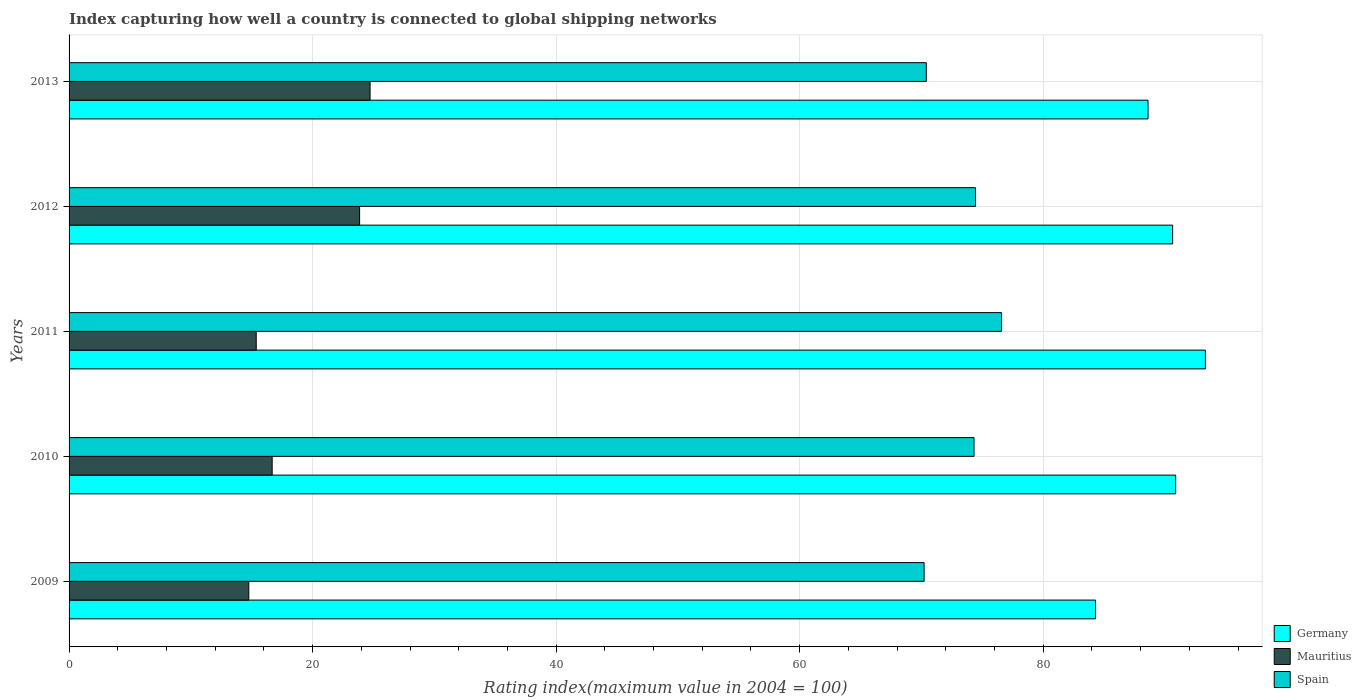How many groups of bars are there?
Give a very brief answer. 5. How many bars are there on the 4th tick from the top?
Your response must be concise. 3. In how many cases, is the number of bars for a given year not equal to the number of legend labels?
Your answer should be very brief. 0. What is the rating index in Mauritius in 2010?
Offer a very short reply. 16.68. Across all years, what is the maximum rating index in Germany?
Ensure brevity in your answer.  93.32. Across all years, what is the minimum rating index in Germany?
Give a very brief answer. 84.3. What is the total rating index in Mauritius in the graph?
Make the answer very short. 95.39. What is the difference between the rating index in Mauritius in 2009 and the rating index in Spain in 2011?
Offer a very short reply. -61.82. What is the average rating index in Spain per year?
Your response must be concise. 73.19. In the year 2009, what is the difference between the rating index in Spain and rating index in Germany?
Your answer should be very brief. -14.08. What is the ratio of the rating index in Germany in 2011 to that in 2013?
Your answer should be compact. 1.05. Is the rating index in Spain in 2011 less than that in 2012?
Give a very brief answer. No. What is the difference between the highest and the second highest rating index in Spain?
Your answer should be very brief. 2.14. What is the difference between the highest and the lowest rating index in Germany?
Keep it short and to the point. 9.02. In how many years, is the rating index in Germany greater than the average rating index in Germany taken over all years?
Provide a succinct answer. 3. What does the 2nd bar from the bottom in 2013 represents?
Your answer should be very brief. Mauritius. How many bars are there?
Provide a short and direct response. 15. Does the graph contain any zero values?
Provide a short and direct response. No. How are the legend labels stacked?
Ensure brevity in your answer.  Vertical. What is the title of the graph?
Your response must be concise. Index capturing how well a country is connected to global shipping networks. Does "Serbia" appear as one of the legend labels in the graph?
Your answer should be very brief. No. What is the label or title of the X-axis?
Make the answer very short. Rating index(maximum value in 2004 = 100). What is the label or title of the Y-axis?
Keep it short and to the point. Years. What is the Rating index(maximum value in 2004 = 100) in Germany in 2009?
Your answer should be compact. 84.3. What is the Rating index(maximum value in 2004 = 100) of Mauritius in 2009?
Make the answer very short. 14.76. What is the Rating index(maximum value in 2004 = 100) in Spain in 2009?
Provide a short and direct response. 70.22. What is the Rating index(maximum value in 2004 = 100) in Germany in 2010?
Give a very brief answer. 90.88. What is the Rating index(maximum value in 2004 = 100) of Mauritius in 2010?
Your answer should be compact. 16.68. What is the Rating index(maximum value in 2004 = 100) in Spain in 2010?
Your answer should be very brief. 74.32. What is the Rating index(maximum value in 2004 = 100) in Germany in 2011?
Your response must be concise. 93.32. What is the Rating index(maximum value in 2004 = 100) in Mauritius in 2011?
Provide a succinct answer. 15.37. What is the Rating index(maximum value in 2004 = 100) of Spain in 2011?
Your answer should be very brief. 76.58. What is the Rating index(maximum value in 2004 = 100) of Germany in 2012?
Make the answer very short. 90.63. What is the Rating index(maximum value in 2004 = 100) in Mauritius in 2012?
Offer a very short reply. 23.86. What is the Rating index(maximum value in 2004 = 100) of Spain in 2012?
Your answer should be compact. 74.44. What is the Rating index(maximum value in 2004 = 100) of Germany in 2013?
Give a very brief answer. 88.61. What is the Rating index(maximum value in 2004 = 100) in Mauritius in 2013?
Offer a terse response. 24.72. What is the Rating index(maximum value in 2004 = 100) in Spain in 2013?
Your answer should be compact. 70.4. Across all years, what is the maximum Rating index(maximum value in 2004 = 100) in Germany?
Give a very brief answer. 93.32. Across all years, what is the maximum Rating index(maximum value in 2004 = 100) of Mauritius?
Give a very brief answer. 24.72. Across all years, what is the maximum Rating index(maximum value in 2004 = 100) of Spain?
Your answer should be compact. 76.58. Across all years, what is the minimum Rating index(maximum value in 2004 = 100) in Germany?
Ensure brevity in your answer.  84.3. Across all years, what is the minimum Rating index(maximum value in 2004 = 100) of Mauritius?
Give a very brief answer. 14.76. Across all years, what is the minimum Rating index(maximum value in 2004 = 100) in Spain?
Keep it short and to the point. 70.22. What is the total Rating index(maximum value in 2004 = 100) in Germany in the graph?
Keep it short and to the point. 447.74. What is the total Rating index(maximum value in 2004 = 100) of Mauritius in the graph?
Your response must be concise. 95.39. What is the total Rating index(maximum value in 2004 = 100) in Spain in the graph?
Your answer should be compact. 365.96. What is the difference between the Rating index(maximum value in 2004 = 100) in Germany in 2009 and that in 2010?
Give a very brief answer. -6.58. What is the difference between the Rating index(maximum value in 2004 = 100) in Mauritius in 2009 and that in 2010?
Your answer should be very brief. -1.92. What is the difference between the Rating index(maximum value in 2004 = 100) in Germany in 2009 and that in 2011?
Your answer should be compact. -9.02. What is the difference between the Rating index(maximum value in 2004 = 100) in Mauritius in 2009 and that in 2011?
Your answer should be very brief. -0.61. What is the difference between the Rating index(maximum value in 2004 = 100) in Spain in 2009 and that in 2011?
Ensure brevity in your answer.  -6.36. What is the difference between the Rating index(maximum value in 2004 = 100) in Germany in 2009 and that in 2012?
Offer a terse response. -6.33. What is the difference between the Rating index(maximum value in 2004 = 100) in Mauritius in 2009 and that in 2012?
Keep it short and to the point. -9.1. What is the difference between the Rating index(maximum value in 2004 = 100) of Spain in 2009 and that in 2012?
Offer a terse response. -4.22. What is the difference between the Rating index(maximum value in 2004 = 100) in Germany in 2009 and that in 2013?
Give a very brief answer. -4.31. What is the difference between the Rating index(maximum value in 2004 = 100) in Mauritius in 2009 and that in 2013?
Provide a short and direct response. -9.96. What is the difference between the Rating index(maximum value in 2004 = 100) in Spain in 2009 and that in 2013?
Make the answer very short. -0.18. What is the difference between the Rating index(maximum value in 2004 = 100) in Germany in 2010 and that in 2011?
Offer a very short reply. -2.44. What is the difference between the Rating index(maximum value in 2004 = 100) of Mauritius in 2010 and that in 2011?
Give a very brief answer. 1.31. What is the difference between the Rating index(maximum value in 2004 = 100) in Spain in 2010 and that in 2011?
Make the answer very short. -2.26. What is the difference between the Rating index(maximum value in 2004 = 100) in Germany in 2010 and that in 2012?
Offer a terse response. 0.25. What is the difference between the Rating index(maximum value in 2004 = 100) in Mauritius in 2010 and that in 2012?
Make the answer very short. -7.18. What is the difference between the Rating index(maximum value in 2004 = 100) in Spain in 2010 and that in 2012?
Offer a terse response. -0.12. What is the difference between the Rating index(maximum value in 2004 = 100) in Germany in 2010 and that in 2013?
Offer a terse response. 2.27. What is the difference between the Rating index(maximum value in 2004 = 100) of Mauritius in 2010 and that in 2013?
Make the answer very short. -8.04. What is the difference between the Rating index(maximum value in 2004 = 100) in Spain in 2010 and that in 2013?
Your answer should be very brief. 3.92. What is the difference between the Rating index(maximum value in 2004 = 100) of Germany in 2011 and that in 2012?
Offer a very short reply. 2.69. What is the difference between the Rating index(maximum value in 2004 = 100) of Mauritius in 2011 and that in 2012?
Provide a succinct answer. -8.49. What is the difference between the Rating index(maximum value in 2004 = 100) of Spain in 2011 and that in 2012?
Offer a terse response. 2.14. What is the difference between the Rating index(maximum value in 2004 = 100) in Germany in 2011 and that in 2013?
Offer a very short reply. 4.71. What is the difference between the Rating index(maximum value in 2004 = 100) in Mauritius in 2011 and that in 2013?
Your response must be concise. -9.35. What is the difference between the Rating index(maximum value in 2004 = 100) of Spain in 2011 and that in 2013?
Make the answer very short. 6.18. What is the difference between the Rating index(maximum value in 2004 = 100) of Germany in 2012 and that in 2013?
Your answer should be compact. 2.02. What is the difference between the Rating index(maximum value in 2004 = 100) in Mauritius in 2012 and that in 2013?
Offer a very short reply. -0.86. What is the difference between the Rating index(maximum value in 2004 = 100) in Spain in 2012 and that in 2013?
Provide a short and direct response. 4.04. What is the difference between the Rating index(maximum value in 2004 = 100) of Germany in 2009 and the Rating index(maximum value in 2004 = 100) of Mauritius in 2010?
Provide a short and direct response. 67.62. What is the difference between the Rating index(maximum value in 2004 = 100) of Germany in 2009 and the Rating index(maximum value in 2004 = 100) of Spain in 2010?
Give a very brief answer. 9.98. What is the difference between the Rating index(maximum value in 2004 = 100) of Mauritius in 2009 and the Rating index(maximum value in 2004 = 100) of Spain in 2010?
Ensure brevity in your answer.  -59.56. What is the difference between the Rating index(maximum value in 2004 = 100) in Germany in 2009 and the Rating index(maximum value in 2004 = 100) in Mauritius in 2011?
Your response must be concise. 68.93. What is the difference between the Rating index(maximum value in 2004 = 100) in Germany in 2009 and the Rating index(maximum value in 2004 = 100) in Spain in 2011?
Keep it short and to the point. 7.72. What is the difference between the Rating index(maximum value in 2004 = 100) in Mauritius in 2009 and the Rating index(maximum value in 2004 = 100) in Spain in 2011?
Your answer should be compact. -61.82. What is the difference between the Rating index(maximum value in 2004 = 100) in Germany in 2009 and the Rating index(maximum value in 2004 = 100) in Mauritius in 2012?
Keep it short and to the point. 60.44. What is the difference between the Rating index(maximum value in 2004 = 100) in Germany in 2009 and the Rating index(maximum value in 2004 = 100) in Spain in 2012?
Give a very brief answer. 9.86. What is the difference between the Rating index(maximum value in 2004 = 100) in Mauritius in 2009 and the Rating index(maximum value in 2004 = 100) in Spain in 2012?
Provide a short and direct response. -59.68. What is the difference between the Rating index(maximum value in 2004 = 100) in Germany in 2009 and the Rating index(maximum value in 2004 = 100) in Mauritius in 2013?
Make the answer very short. 59.58. What is the difference between the Rating index(maximum value in 2004 = 100) in Mauritius in 2009 and the Rating index(maximum value in 2004 = 100) in Spain in 2013?
Provide a succinct answer. -55.64. What is the difference between the Rating index(maximum value in 2004 = 100) of Germany in 2010 and the Rating index(maximum value in 2004 = 100) of Mauritius in 2011?
Provide a short and direct response. 75.51. What is the difference between the Rating index(maximum value in 2004 = 100) in Mauritius in 2010 and the Rating index(maximum value in 2004 = 100) in Spain in 2011?
Your response must be concise. -59.9. What is the difference between the Rating index(maximum value in 2004 = 100) in Germany in 2010 and the Rating index(maximum value in 2004 = 100) in Mauritius in 2012?
Your response must be concise. 67.02. What is the difference between the Rating index(maximum value in 2004 = 100) of Germany in 2010 and the Rating index(maximum value in 2004 = 100) of Spain in 2012?
Offer a very short reply. 16.44. What is the difference between the Rating index(maximum value in 2004 = 100) of Mauritius in 2010 and the Rating index(maximum value in 2004 = 100) of Spain in 2012?
Provide a short and direct response. -57.76. What is the difference between the Rating index(maximum value in 2004 = 100) in Germany in 2010 and the Rating index(maximum value in 2004 = 100) in Mauritius in 2013?
Offer a very short reply. 66.16. What is the difference between the Rating index(maximum value in 2004 = 100) of Germany in 2010 and the Rating index(maximum value in 2004 = 100) of Spain in 2013?
Your answer should be compact. 20.48. What is the difference between the Rating index(maximum value in 2004 = 100) in Mauritius in 2010 and the Rating index(maximum value in 2004 = 100) in Spain in 2013?
Provide a short and direct response. -53.72. What is the difference between the Rating index(maximum value in 2004 = 100) of Germany in 2011 and the Rating index(maximum value in 2004 = 100) of Mauritius in 2012?
Provide a succinct answer. 69.46. What is the difference between the Rating index(maximum value in 2004 = 100) of Germany in 2011 and the Rating index(maximum value in 2004 = 100) of Spain in 2012?
Make the answer very short. 18.88. What is the difference between the Rating index(maximum value in 2004 = 100) of Mauritius in 2011 and the Rating index(maximum value in 2004 = 100) of Spain in 2012?
Keep it short and to the point. -59.07. What is the difference between the Rating index(maximum value in 2004 = 100) in Germany in 2011 and the Rating index(maximum value in 2004 = 100) in Mauritius in 2013?
Ensure brevity in your answer.  68.6. What is the difference between the Rating index(maximum value in 2004 = 100) in Germany in 2011 and the Rating index(maximum value in 2004 = 100) in Spain in 2013?
Make the answer very short. 22.92. What is the difference between the Rating index(maximum value in 2004 = 100) of Mauritius in 2011 and the Rating index(maximum value in 2004 = 100) of Spain in 2013?
Provide a short and direct response. -55.03. What is the difference between the Rating index(maximum value in 2004 = 100) in Germany in 2012 and the Rating index(maximum value in 2004 = 100) in Mauritius in 2013?
Offer a terse response. 65.91. What is the difference between the Rating index(maximum value in 2004 = 100) of Germany in 2012 and the Rating index(maximum value in 2004 = 100) of Spain in 2013?
Provide a short and direct response. 20.23. What is the difference between the Rating index(maximum value in 2004 = 100) in Mauritius in 2012 and the Rating index(maximum value in 2004 = 100) in Spain in 2013?
Your answer should be very brief. -46.54. What is the average Rating index(maximum value in 2004 = 100) in Germany per year?
Ensure brevity in your answer.  89.55. What is the average Rating index(maximum value in 2004 = 100) of Mauritius per year?
Offer a very short reply. 19.08. What is the average Rating index(maximum value in 2004 = 100) in Spain per year?
Your response must be concise. 73.19. In the year 2009, what is the difference between the Rating index(maximum value in 2004 = 100) in Germany and Rating index(maximum value in 2004 = 100) in Mauritius?
Offer a very short reply. 69.54. In the year 2009, what is the difference between the Rating index(maximum value in 2004 = 100) in Germany and Rating index(maximum value in 2004 = 100) in Spain?
Offer a terse response. 14.08. In the year 2009, what is the difference between the Rating index(maximum value in 2004 = 100) in Mauritius and Rating index(maximum value in 2004 = 100) in Spain?
Your answer should be compact. -55.46. In the year 2010, what is the difference between the Rating index(maximum value in 2004 = 100) of Germany and Rating index(maximum value in 2004 = 100) of Mauritius?
Provide a succinct answer. 74.2. In the year 2010, what is the difference between the Rating index(maximum value in 2004 = 100) of Germany and Rating index(maximum value in 2004 = 100) of Spain?
Make the answer very short. 16.56. In the year 2010, what is the difference between the Rating index(maximum value in 2004 = 100) in Mauritius and Rating index(maximum value in 2004 = 100) in Spain?
Ensure brevity in your answer.  -57.64. In the year 2011, what is the difference between the Rating index(maximum value in 2004 = 100) in Germany and Rating index(maximum value in 2004 = 100) in Mauritius?
Your response must be concise. 77.95. In the year 2011, what is the difference between the Rating index(maximum value in 2004 = 100) of Germany and Rating index(maximum value in 2004 = 100) of Spain?
Ensure brevity in your answer.  16.74. In the year 2011, what is the difference between the Rating index(maximum value in 2004 = 100) of Mauritius and Rating index(maximum value in 2004 = 100) of Spain?
Your answer should be very brief. -61.21. In the year 2012, what is the difference between the Rating index(maximum value in 2004 = 100) of Germany and Rating index(maximum value in 2004 = 100) of Mauritius?
Provide a short and direct response. 66.77. In the year 2012, what is the difference between the Rating index(maximum value in 2004 = 100) of Germany and Rating index(maximum value in 2004 = 100) of Spain?
Give a very brief answer. 16.19. In the year 2012, what is the difference between the Rating index(maximum value in 2004 = 100) in Mauritius and Rating index(maximum value in 2004 = 100) in Spain?
Offer a terse response. -50.58. In the year 2013, what is the difference between the Rating index(maximum value in 2004 = 100) in Germany and Rating index(maximum value in 2004 = 100) in Mauritius?
Give a very brief answer. 63.89. In the year 2013, what is the difference between the Rating index(maximum value in 2004 = 100) of Germany and Rating index(maximum value in 2004 = 100) of Spain?
Give a very brief answer. 18.21. In the year 2013, what is the difference between the Rating index(maximum value in 2004 = 100) of Mauritius and Rating index(maximum value in 2004 = 100) of Spain?
Ensure brevity in your answer.  -45.68. What is the ratio of the Rating index(maximum value in 2004 = 100) in Germany in 2009 to that in 2010?
Provide a short and direct response. 0.93. What is the ratio of the Rating index(maximum value in 2004 = 100) of Mauritius in 2009 to that in 2010?
Make the answer very short. 0.88. What is the ratio of the Rating index(maximum value in 2004 = 100) of Spain in 2009 to that in 2010?
Your response must be concise. 0.94. What is the ratio of the Rating index(maximum value in 2004 = 100) in Germany in 2009 to that in 2011?
Your response must be concise. 0.9. What is the ratio of the Rating index(maximum value in 2004 = 100) in Mauritius in 2009 to that in 2011?
Your answer should be very brief. 0.96. What is the ratio of the Rating index(maximum value in 2004 = 100) in Spain in 2009 to that in 2011?
Offer a very short reply. 0.92. What is the ratio of the Rating index(maximum value in 2004 = 100) in Germany in 2009 to that in 2012?
Your answer should be compact. 0.93. What is the ratio of the Rating index(maximum value in 2004 = 100) in Mauritius in 2009 to that in 2012?
Make the answer very short. 0.62. What is the ratio of the Rating index(maximum value in 2004 = 100) of Spain in 2009 to that in 2012?
Make the answer very short. 0.94. What is the ratio of the Rating index(maximum value in 2004 = 100) in Germany in 2009 to that in 2013?
Provide a short and direct response. 0.95. What is the ratio of the Rating index(maximum value in 2004 = 100) of Mauritius in 2009 to that in 2013?
Provide a short and direct response. 0.6. What is the ratio of the Rating index(maximum value in 2004 = 100) in Spain in 2009 to that in 2013?
Make the answer very short. 1. What is the ratio of the Rating index(maximum value in 2004 = 100) of Germany in 2010 to that in 2011?
Provide a succinct answer. 0.97. What is the ratio of the Rating index(maximum value in 2004 = 100) in Mauritius in 2010 to that in 2011?
Provide a short and direct response. 1.09. What is the ratio of the Rating index(maximum value in 2004 = 100) in Spain in 2010 to that in 2011?
Provide a succinct answer. 0.97. What is the ratio of the Rating index(maximum value in 2004 = 100) of Germany in 2010 to that in 2012?
Ensure brevity in your answer.  1. What is the ratio of the Rating index(maximum value in 2004 = 100) of Mauritius in 2010 to that in 2012?
Keep it short and to the point. 0.7. What is the ratio of the Rating index(maximum value in 2004 = 100) in Spain in 2010 to that in 2012?
Offer a very short reply. 1. What is the ratio of the Rating index(maximum value in 2004 = 100) in Germany in 2010 to that in 2013?
Offer a very short reply. 1.03. What is the ratio of the Rating index(maximum value in 2004 = 100) of Mauritius in 2010 to that in 2013?
Offer a very short reply. 0.67. What is the ratio of the Rating index(maximum value in 2004 = 100) in Spain in 2010 to that in 2013?
Provide a short and direct response. 1.06. What is the ratio of the Rating index(maximum value in 2004 = 100) of Germany in 2011 to that in 2012?
Your response must be concise. 1.03. What is the ratio of the Rating index(maximum value in 2004 = 100) in Mauritius in 2011 to that in 2012?
Provide a short and direct response. 0.64. What is the ratio of the Rating index(maximum value in 2004 = 100) in Spain in 2011 to that in 2012?
Your answer should be compact. 1.03. What is the ratio of the Rating index(maximum value in 2004 = 100) of Germany in 2011 to that in 2013?
Give a very brief answer. 1.05. What is the ratio of the Rating index(maximum value in 2004 = 100) of Mauritius in 2011 to that in 2013?
Ensure brevity in your answer.  0.62. What is the ratio of the Rating index(maximum value in 2004 = 100) in Spain in 2011 to that in 2013?
Offer a very short reply. 1.09. What is the ratio of the Rating index(maximum value in 2004 = 100) in Germany in 2012 to that in 2013?
Keep it short and to the point. 1.02. What is the ratio of the Rating index(maximum value in 2004 = 100) in Mauritius in 2012 to that in 2013?
Give a very brief answer. 0.97. What is the ratio of the Rating index(maximum value in 2004 = 100) of Spain in 2012 to that in 2013?
Ensure brevity in your answer.  1.06. What is the difference between the highest and the second highest Rating index(maximum value in 2004 = 100) in Germany?
Your answer should be very brief. 2.44. What is the difference between the highest and the second highest Rating index(maximum value in 2004 = 100) in Mauritius?
Provide a short and direct response. 0.86. What is the difference between the highest and the second highest Rating index(maximum value in 2004 = 100) in Spain?
Make the answer very short. 2.14. What is the difference between the highest and the lowest Rating index(maximum value in 2004 = 100) of Germany?
Keep it short and to the point. 9.02. What is the difference between the highest and the lowest Rating index(maximum value in 2004 = 100) in Mauritius?
Offer a very short reply. 9.96. What is the difference between the highest and the lowest Rating index(maximum value in 2004 = 100) of Spain?
Your response must be concise. 6.36. 